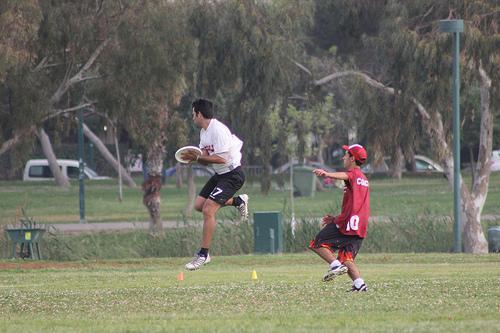How many people are there?
Give a very brief answer. 2. 